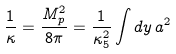Convert formula to latex. <formula><loc_0><loc_0><loc_500><loc_500>\frac { 1 } { \kappa } = \frac { M _ { p } ^ { 2 } } { 8 \pi } = \frac { 1 } { \kappa _ { 5 } ^ { 2 } } \int d y \, a ^ { 2 }</formula> 